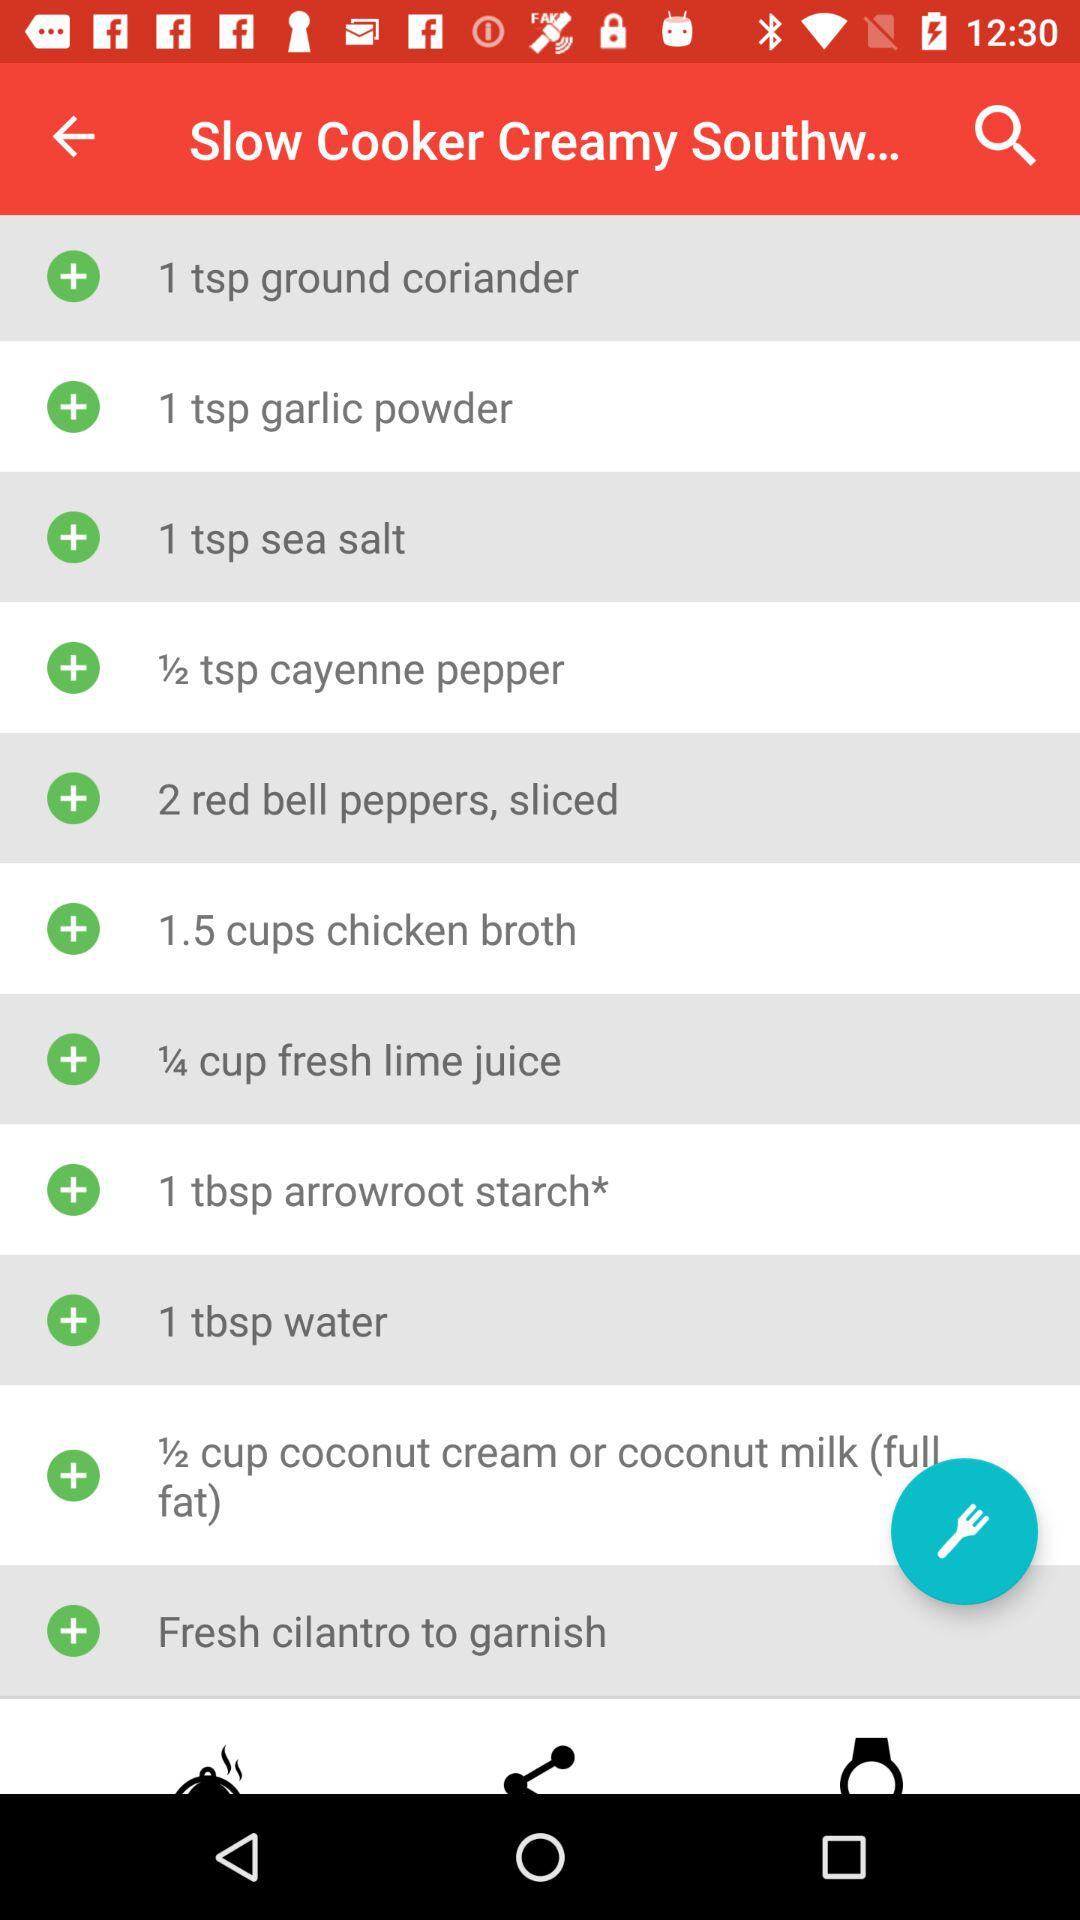How many tablespoons of arrowroot starch are required? There is 1 tbsp of arrowroot starch required. 